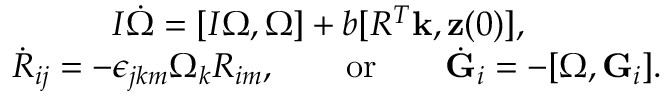<formula> <loc_0><loc_0><loc_500><loc_500>\begin{array} { r } { I \dot { \boldsymbol \Omega } = [ I { \boldsymbol \Omega } , { \boldsymbol \Omega } ] + b [ R ^ { T } { k } , { z } ( 0 ) ] , \quad } \\ { \dot { R } _ { i j } = - \epsilon _ { j k m } \Omega _ { k } R _ { i m } , \quad o r \quad \dot { G } _ { i } = - [ { \boldsymbol \Omega } , { G } _ { i } ] . } \end{array}</formula> 